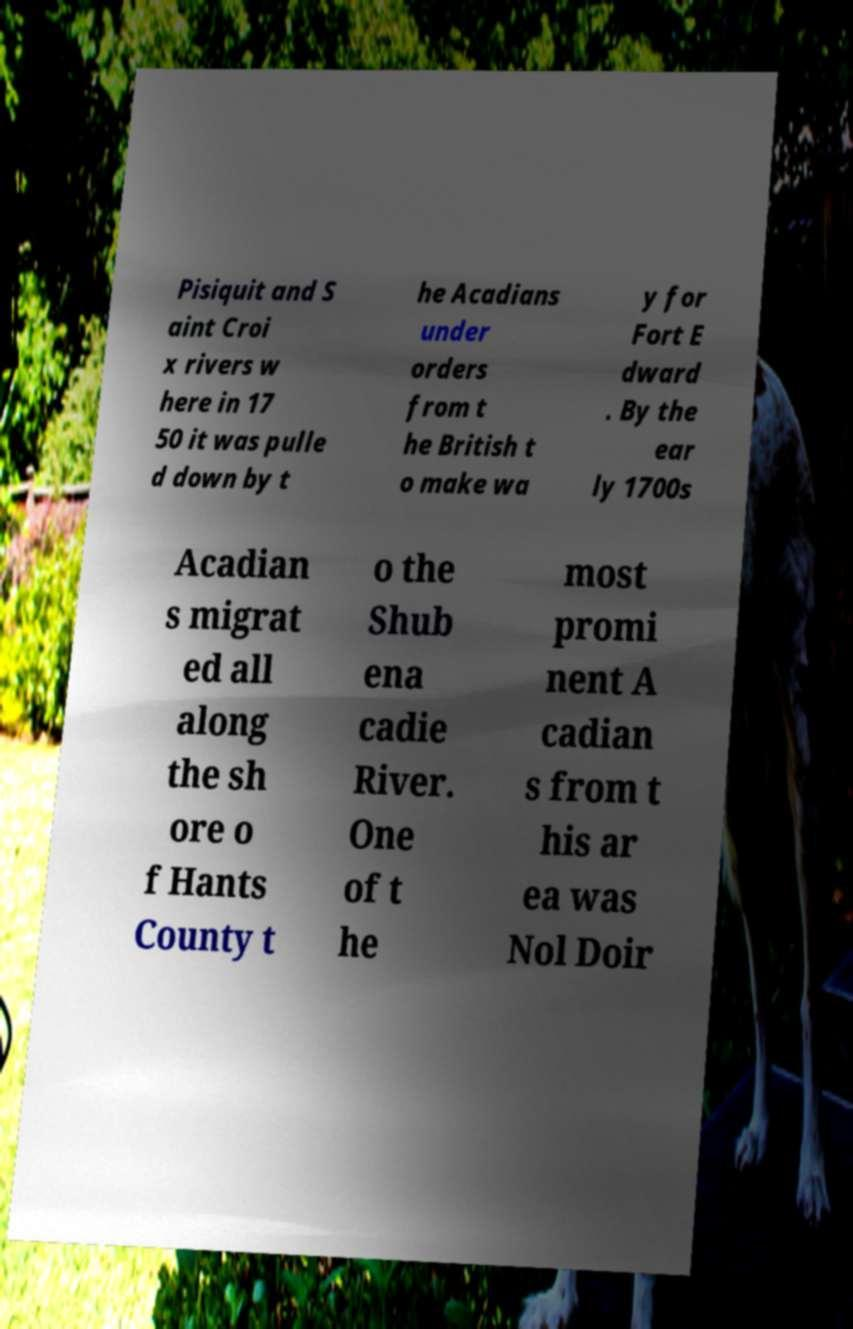For documentation purposes, I need the text within this image transcribed. Could you provide that? Pisiquit and S aint Croi x rivers w here in 17 50 it was pulle d down by t he Acadians under orders from t he British t o make wa y for Fort E dward . By the ear ly 1700s Acadian s migrat ed all along the sh ore o f Hants County t o the Shub ena cadie River. One of t he most promi nent A cadian s from t his ar ea was Nol Doir 